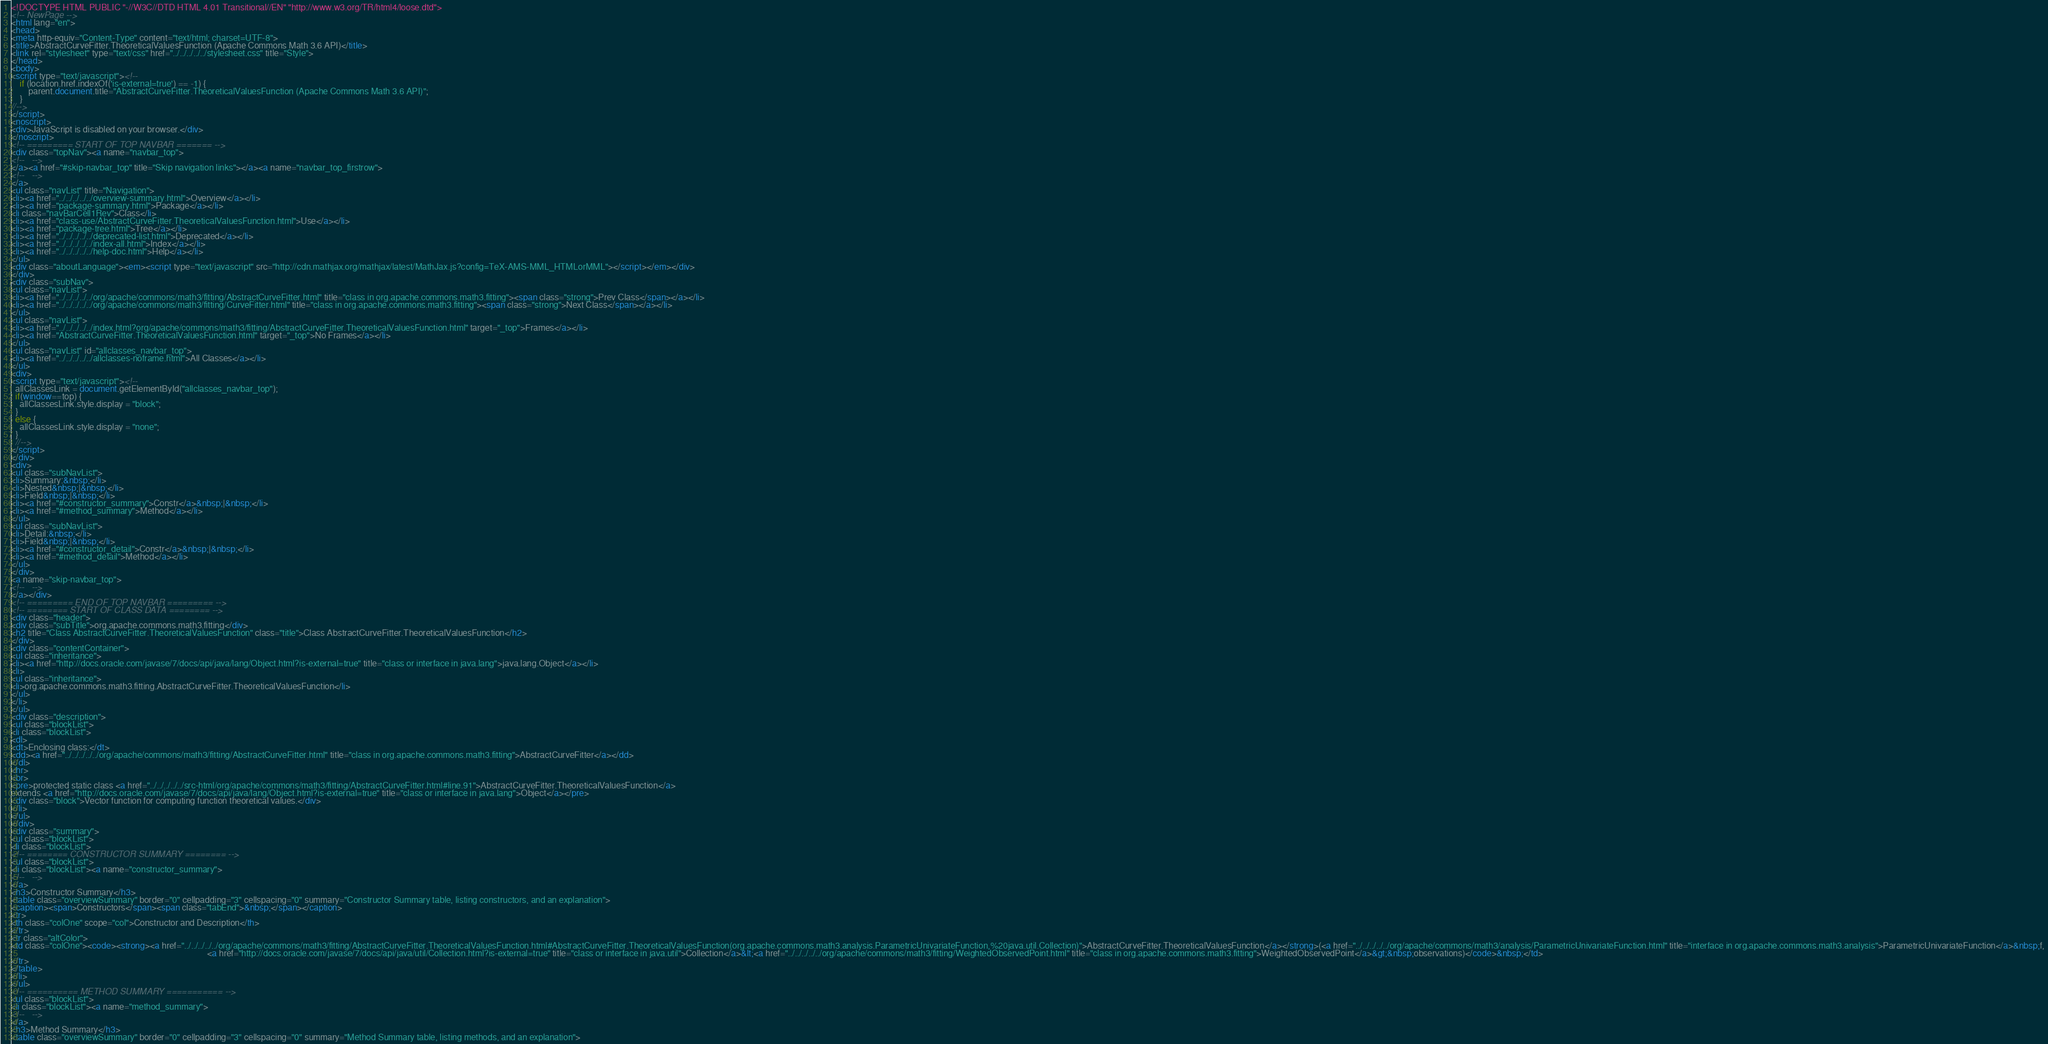<code> <loc_0><loc_0><loc_500><loc_500><_HTML_><!DOCTYPE HTML PUBLIC "-//W3C//DTD HTML 4.01 Transitional//EN" "http://www.w3.org/TR/html4/loose.dtd">
<!-- NewPage -->
<html lang="en">
<head>
<meta http-equiv="Content-Type" content="text/html; charset=UTF-8">
<title>AbstractCurveFitter.TheoreticalValuesFunction (Apache Commons Math 3.6 API)</title>
<link rel="stylesheet" type="text/css" href="../../../../../stylesheet.css" title="Style">
</head>
<body>
<script type="text/javascript"><!--
    if (location.href.indexOf('is-external=true') == -1) {
        parent.document.title="AbstractCurveFitter.TheoreticalValuesFunction (Apache Commons Math 3.6 API)";
    }
//-->
</script>
<noscript>
<div>JavaScript is disabled on your browser.</div>
</noscript>
<!-- ========= START OF TOP NAVBAR ======= -->
<div class="topNav"><a name="navbar_top">
<!--   -->
</a><a href="#skip-navbar_top" title="Skip navigation links"></a><a name="navbar_top_firstrow">
<!--   -->
</a>
<ul class="navList" title="Navigation">
<li><a href="../../../../../overview-summary.html">Overview</a></li>
<li><a href="package-summary.html">Package</a></li>
<li class="navBarCell1Rev">Class</li>
<li><a href="class-use/AbstractCurveFitter.TheoreticalValuesFunction.html">Use</a></li>
<li><a href="package-tree.html">Tree</a></li>
<li><a href="../../../../../deprecated-list.html">Deprecated</a></li>
<li><a href="../../../../../index-all.html">Index</a></li>
<li><a href="../../../../../help-doc.html">Help</a></li>
</ul>
<div class="aboutLanguage"><em><script type="text/javascript" src="http://cdn.mathjax.org/mathjax/latest/MathJax.js?config=TeX-AMS-MML_HTMLorMML"></script></em></div>
</div>
<div class="subNav">
<ul class="navList">
<li><a href="../../../../../org/apache/commons/math3/fitting/AbstractCurveFitter.html" title="class in org.apache.commons.math3.fitting"><span class="strong">Prev Class</span></a></li>
<li><a href="../../../../../org/apache/commons/math3/fitting/CurveFitter.html" title="class in org.apache.commons.math3.fitting"><span class="strong">Next Class</span></a></li>
</ul>
<ul class="navList">
<li><a href="../../../../../index.html?org/apache/commons/math3/fitting/AbstractCurveFitter.TheoreticalValuesFunction.html" target="_top">Frames</a></li>
<li><a href="AbstractCurveFitter.TheoreticalValuesFunction.html" target="_top">No Frames</a></li>
</ul>
<ul class="navList" id="allclasses_navbar_top">
<li><a href="../../../../../allclasses-noframe.html">All Classes</a></li>
</ul>
<div>
<script type="text/javascript"><!--
  allClassesLink = document.getElementById("allclasses_navbar_top");
  if(window==top) {
    allClassesLink.style.display = "block";
  }
  else {
    allClassesLink.style.display = "none";
  }
  //-->
</script>
</div>
<div>
<ul class="subNavList">
<li>Summary:&nbsp;</li>
<li>Nested&nbsp;|&nbsp;</li>
<li>Field&nbsp;|&nbsp;</li>
<li><a href="#constructor_summary">Constr</a>&nbsp;|&nbsp;</li>
<li><a href="#method_summary">Method</a></li>
</ul>
<ul class="subNavList">
<li>Detail:&nbsp;</li>
<li>Field&nbsp;|&nbsp;</li>
<li><a href="#constructor_detail">Constr</a>&nbsp;|&nbsp;</li>
<li><a href="#method_detail">Method</a></li>
</ul>
</div>
<a name="skip-navbar_top">
<!--   -->
</a></div>
<!-- ========= END OF TOP NAVBAR ========= -->
<!-- ======== START OF CLASS DATA ======== -->
<div class="header">
<div class="subTitle">org.apache.commons.math3.fitting</div>
<h2 title="Class AbstractCurveFitter.TheoreticalValuesFunction" class="title">Class AbstractCurveFitter.TheoreticalValuesFunction</h2>
</div>
<div class="contentContainer">
<ul class="inheritance">
<li><a href="http://docs.oracle.com/javase/7/docs/api/java/lang/Object.html?is-external=true" title="class or interface in java.lang">java.lang.Object</a></li>
<li>
<ul class="inheritance">
<li>org.apache.commons.math3.fitting.AbstractCurveFitter.TheoreticalValuesFunction</li>
</ul>
</li>
</ul>
<div class="description">
<ul class="blockList">
<li class="blockList">
<dl>
<dt>Enclosing class:</dt>
<dd><a href="../../../../../org/apache/commons/math3/fitting/AbstractCurveFitter.html" title="class in org.apache.commons.math3.fitting">AbstractCurveFitter</a></dd>
</dl>
<hr>
<br>
<pre>protected static class <a href="../../../../../src-html/org/apache/commons/math3/fitting/AbstractCurveFitter.html#line.91">AbstractCurveFitter.TheoreticalValuesFunction</a>
extends <a href="http://docs.oracle.com/javase/7/docs/api/java/lang/Object.html?is-external=true" title="class or interface in java.lang">Object</a></pre>
<div class="block">Vector function for computing function theoretical values.</div>
</li>
</ul>
</div>
<div class="summary">
<ul class="blockList">
<li class="blockList">
<!-- ======== CONSTRUCTOR SUMMARY ======== -->
<ul class="blockList">
<li class="blockList"><a name="constructor_summary">
<!--   -->
</a>
<h3>Constructor Summary</h3>
<table class="overviewSummary" border="0" cellpadding="3" cellspacing="0" summary="Constructor Summary table, listing constructors, and an explanation">
<caption><span>Constructors</span><span class="tabEnd">&nbsp;</span></caption>
<tr>
<th class="colOne" scope="col">Constructor and Description</th>
</tr>
<tr class="altColor">
<td class="colOne"><code><strong><a href="../../../../../org/apache/commons/math3/fitting/AbstractCurveFitter.TheoreticalValuesFunction.html#AbstractCurveFitter.TheoreticalValuesFunction(org.apache.commons.math3.analysis.ParametricUnivariateFunction,%20java.util.Collection)">AbstractCurveFitter.TheoreticalValuesFunction</a></strong>(<a href="../../../../../org/apache/commons/math3/analysis/ParametricUnivariateFunction.html" title="interface in org.apache.commons.math3.analysis">ParametricUnivariateFunction</a>&nbsp;f,
                                                                                          <a href="http://docs.oracle.com/javase/7/docs/api/java/util/Collection.html?is-external=true" title="class or interface in java.util">Collection</a>&lt;<a href="../../../../../org/apache/commons/math3/fitting/WeightedObservedPoint.html" title="class in org.apache.commons.math3.fitting">WeightedObservedPoint</a>&gt;&nbsp;observations)</code>&nbsp;</td>
</tr>
</table>
</li>
</ul>
<!-- ========== METHOD SUMMARY =========== -->
<ul class="blockList">
<li class="blockList"><a name="method_summary">
<!--   -->
</a>
<h3>Method Summary</h3>
<table class="overviewSummary" border="0" cellpadding="3" cellspacing="0" summary="Method Summary table, listing methods, and an explanation"></code> 